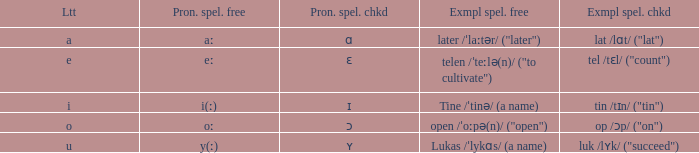What is Example Spelled Free, when Example Spelled Checked is "op /ɔp/ ("on")"? Open /ˈoːpə(n)/ ("open"). 